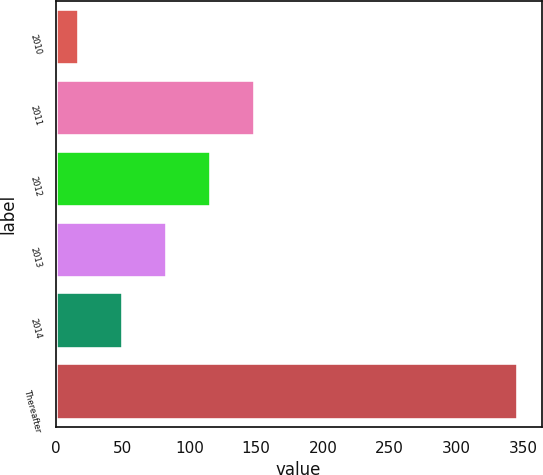Convert chart to OTSL. <chart><loc_0><loc_0><loc_500><loc_500><bar_chart><fcel>2010<fcel>2011<fcel>2012<fcel>2013<fcel>2014<fcel>Thereafter<nl><fcel>17.2<fcel>148.84<fcel>115.93<fcel>83.02<fcel>50.11<fcel>346.3<nl></chart> 